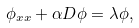Convert formula to latex. <formula><loc_0><loc_0><loc_500><loc_500>\phi _ { x x } + \alpha D \phi = \lambda \phi ,</formula> 